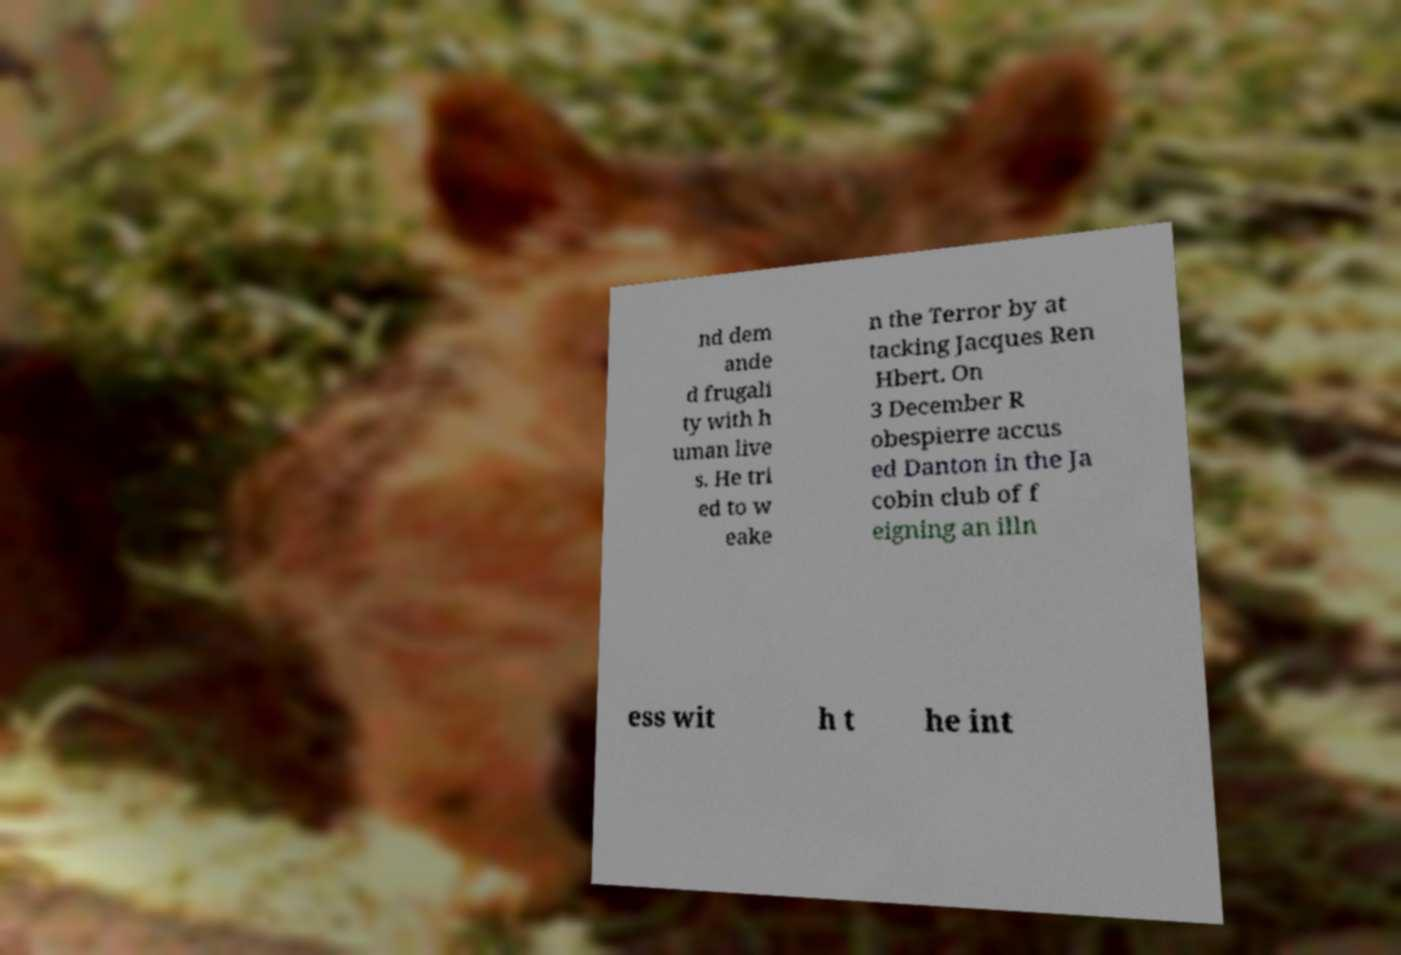Please identify and transcribe the text found in this image. nd dem ande d frugali ty with h uman live s. He tri ed to w eake n the Terror by at tacking Jacques Ren Hbert. On 3 December R obespierre accus ed Danton in the Ja cobin club of f eigning an illn ess wit h t he int 